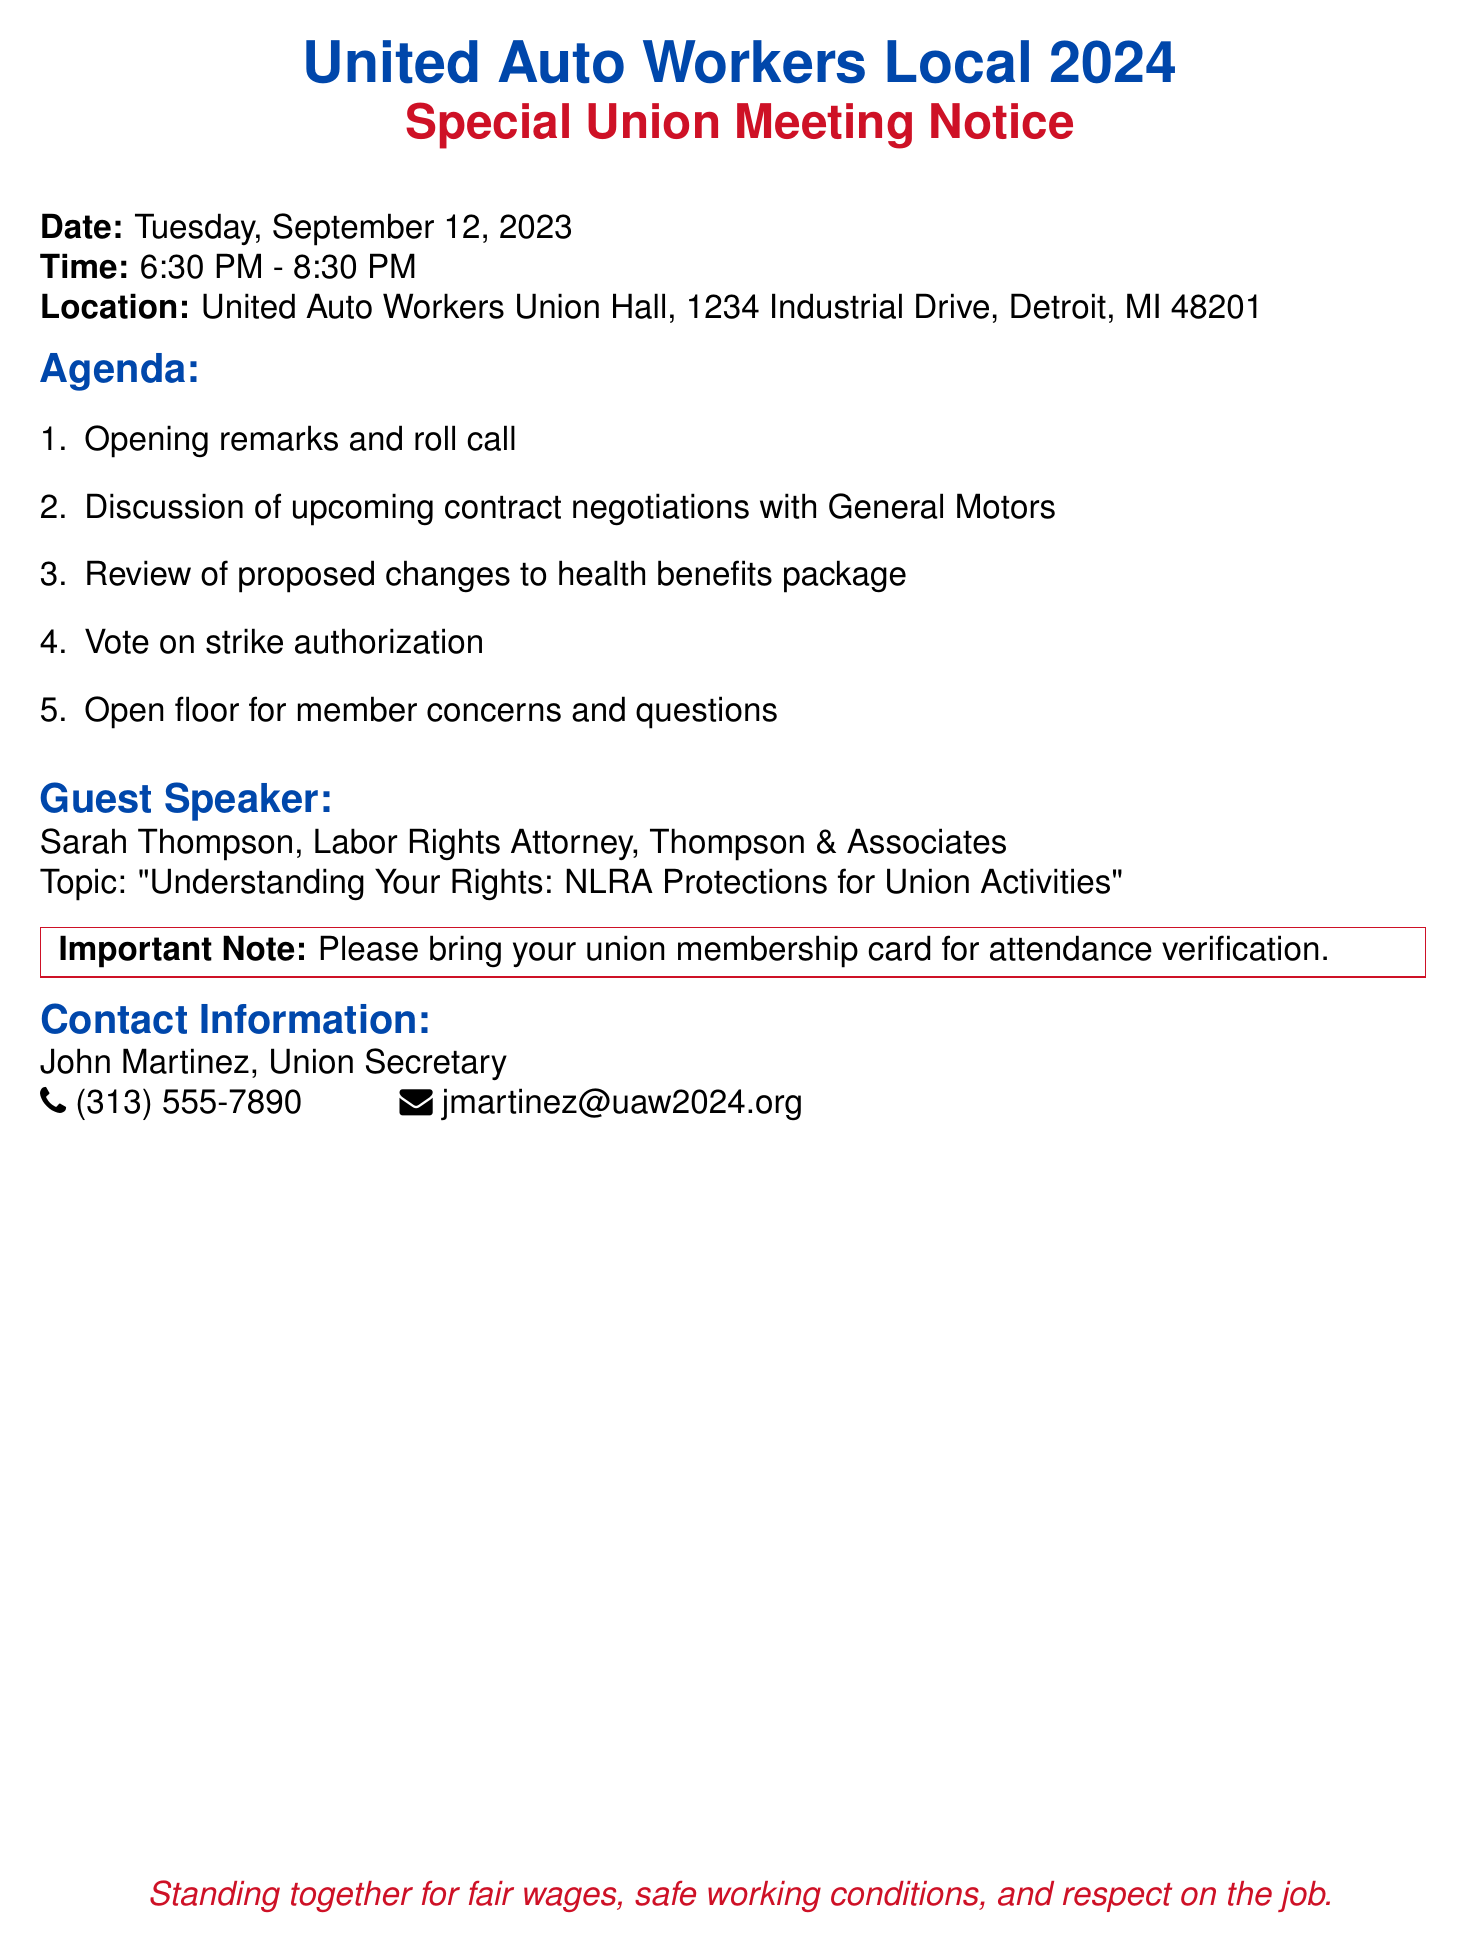What is the date of the meeting? The document states the date of the meeting as Tuesday, September 12, 2023.
Answer: Tuesday, September 12, 2023 What time does the union meeting start? The document lists the starting time of the meeting as 6:30 PM.
Answer: 6:30 PM Where is the location of the union meeting? The location is provided in the document as United Auto Workers Union Hall, 1234 Industrial Drive, Detroit, MI 48201.
Answer: United Auto Workers Union Hall, 1234 Industrial Drive, Detroit, MI 48201 Who is the guest speaker? The guest speaker's name is mentioned in the document as Sarah Thompson.
Answer: Sarah Thompson What is the topic of the guest speaker's talk? The document lists the topic of the guest speaker's talk as "Understanding Your Rights: NLRA Protections for Union Activities".
Answer: Understanding Your Rights: NLRA Protections for Union Activities How many agenda items are listed for the meeting? The document enumerates five agenda items for the meeting.
Answer: Five What is the important note for attendees? The important note for attendees in the document states to bring your union membership card for attendance verification.
Answer: Bring your union membership card for attendance verification Who should be contacted for more information? The document provides contact information for John Martinez, the Union Secretary.
Answer: John Martinez What is the phone number for the Union Secretary? The document includes the phone number as (313) 555-7890.
Answer: (313) 555-7890 